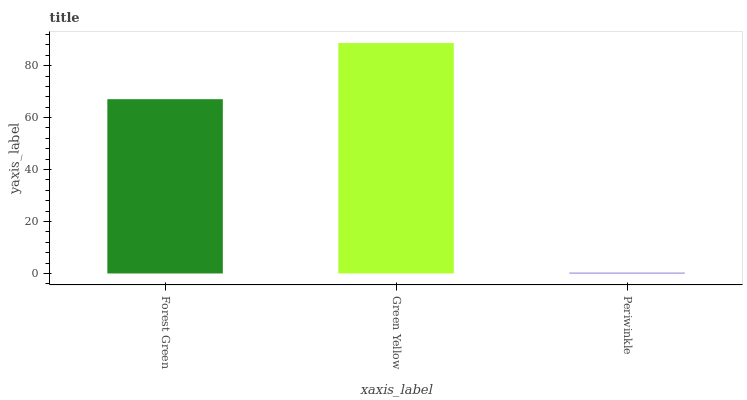Is Periwinkle the minimum?
Answer yes or no. Yes. Is Green Yellow the maximum?
Answer yes or no. Yes. Is Green Yellow the minimum?
Answer yes or no. No. Is Periwinkle the maximum?
Answer yes or no. No. Is Green Yellow greater than Periwinkle?
Answer yes or no. Yes. Is Periwinkle less than Green Yellow?
Answer yes or no. Yes. Is Periwinkle greater than Green Yellow?
Answer yes or no. No. Is Green Yellow less than Periwinkle?
Answer yes or no. No. Is Forest Green the high median?
Answer yes or no. Yes. Is Forest Green the low median?
Answer yes or no. Yes. Is Green Yellow the high median?
Answer yes or no. No. Is Green Yellow the low median?
Answer yes or no. No. 